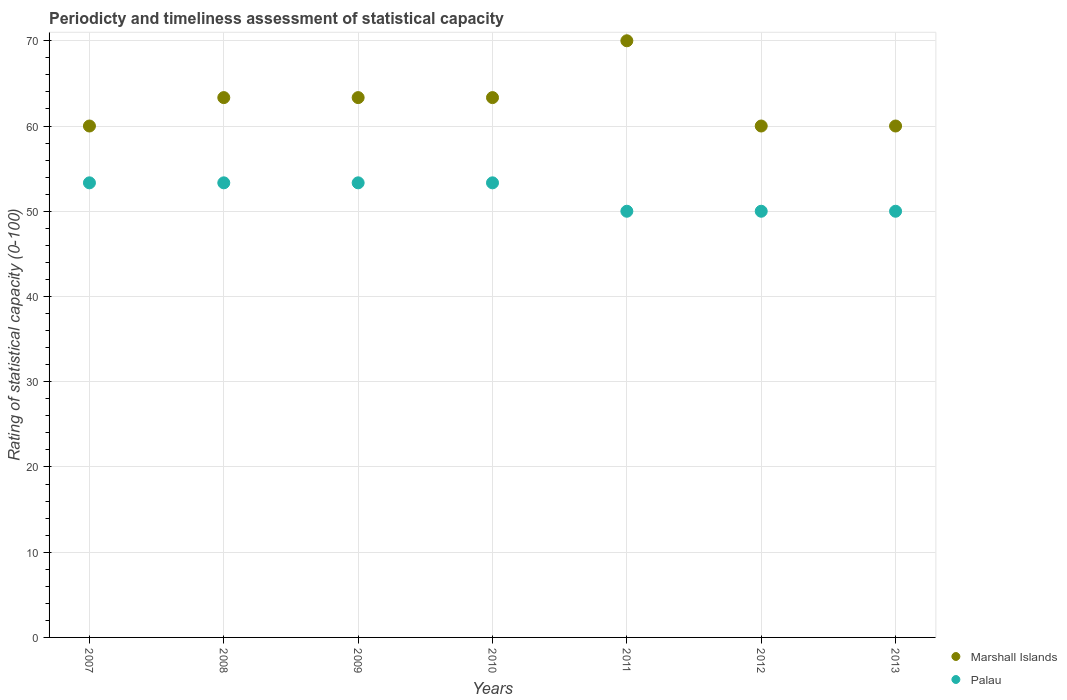How many different coloured dotlines are there?
Give a very brief answer. 2. Is the number of dotlines equal to the number of legend labels?
Your answer should be very brief. Yes. What is the total rating of statistical capacity in Palau in the graph?
Give a very brief answer. 363.33. What is the difference between the rating of statistical capacity in Marshall Islands in 2009 and the rating of statistical capacity in Palau in 2007?
Keep it short and to the point. 10. What is the average rating of statistical capacity in Palau per year?
Make the answer very short. 51.9. In the year 2007, what is the difference between the rating of statistical capacity in Marshall Islands and rating of statistical capacity in Palau?
Ensure brevity in your answer.  6.67. What is the ratio of the rating of statistical capacity in Marshall Islands in 2010 to that in 2012?
Offer a terse response. 1.06. Is the rating of statistical capacity in Palau in 2007 less than that in 2011?
Your response must be concise. No. Is the difference between the rating of statistical capacity in Marshall Islands in 2007 and 2010 greater than the difference between the rating of statistical capacity in Palau in 2007 and 2010?
Ensure brevity in your answer.  No. What is the difference between the highest and the lowest rating of statistical capacity in Palau?
Offer a terse response. 3.33. In how many years, is the rating of statistical capacity in Palau greater than the average rating of statistical capacity in Palau taken over all years?
Offer a terse response. 4. Is the sum of the rating of statistical capacity in Palau in 2011 and 2012 greater than the maximum rating of statistical capacity in Marshall Islands across all years?
Give a very brief answer. Yes. Is the rating of statistical capacity in Palau strictly less than the rating of statistical capacity in Marshall Islands over the years?
Give a very brief answer. Yes. What is the difference between two consecutive major ticks on the Y-axis?
Your response must be concise. 10. Does the graph contain any zero values?
Make the answer very short. No. Does the graph contain grids?
Make the answer very short. Yes. What is the title of the graph?
Your response must be concise. Periodicty and timeliness assessment of statistical capacity. Does "Moldova" appear as one of the legend labels in the graph?
Keep it short and to the point. No. What is the label or title of the Y-axis?
Offer a terse response. Rating of statistical capacity (0-100). What is the Rating of statistical capacity (0-100) in Marshall Islands in 2007?
Your response must be concise. 60. What is the Rating of statistical capacity (0-100) of Palau in 2007?
Offer a very short reply. 53.33. What is the Rating of statistical capacity (0-100) of Marshall Islands in 2008?
Your answer should be very brief. 63.33. What is the Rating of statistical capacity (0-100) in Palau in 2008?
Provide a succinct answer. 53.33. What is the Rating of statistical capacity (0-100) in Marshall Islands in 2009?
Give a very brief answer. 63.33. What is the Rating of statistical capacity (0-100) in Palau in 2009?
Keep it short and to the point. 53.33. What is the Rating of statistical capacity (0-100) of Marshall Islands in 2010?
Ensure brevity in your answer.  63.33. What is the Rating of statistical capacity (0-100) of Palau in 2010?
Make the answer very short. 53.33. What is the Rating of statistical capacity (0-100) in Marshall Islands in 2012?
Your answer should be very brief. 60. What is the Rating of statistical capacity (0-100) in Palau in 2012?
Offer a very short reply. 50. What is the Rating of statistical capacity (0-100) in Marshall Islands in 2013?
Your answer should be very brief. 60. What is the Rating of statistical capacity (0-100) of Palau in 2013?
Your response must be concise. 50. Across all years, what is the maximum Rating of statistical capacity (0-100) of Palau?
Ensure brevity in your answer.  53.33. What is the total Rating of statistical capacity (0-100) in Marshall Islands in the graph?
Provide a succinct answer. 440. What is the total Rating of statistical capacity (0-100) of Palau in the graph?
Your answer should be very brief. 363.33. What is the difference between the Rating of statistical capacity (0-100) of Marshall Islands in 2007 and that in 2008?
Ensure brevity in your answer.  -3.33. What is the difference between the Rating of statistical capacity (0-100) in Marshall Islands in 2007 and that in 2010?
Ensure brevity in your answer.  -3.33. What is the difference between the Rating of statistical capacity (0-100) in Palau in 2007 and that in 2010?
Your response must be concise. 0. What is the difference between the Rating of statistical capacity (0-100) of Marshall Islands in 2007 and that in 2011?
Offer a terse response. -10. What is the difference between the Rating of statistical capacity (0-100) of Palau in 2007 and that in 2011?
Your response must be concise. 3.33. What is the difference between the Rating of statistical capacity (0-100) in Palau in 2007 and that in 2012?
Give a very brief answer. 3.33. What is the difference between the Rating of statistical capacity (0-100) of Marshall Islands in 2007 and that in 2013?
Make the answer very short. 0. What is the difference between the Rating of statistical capacity (0-100) of Palau in 2008 and that in 2009?
Offer a terse response. 0. What is the difference between the Rating of statistical capacity (0-100) in Marshall Islands in 2008 and that in 2010?
Make the answer very short. 0. What is the difference between the Rating of statistical capacity (0-100) of Marshall Islands in 2008 and that in 2011?
Your answer should be very brief. -6.67. What is the difference between the Rating of statistical capacity (0-100) of Marshall Islands in 2008 and that in 2012?
Keep it short and to the point. 3.33. What is the difference between the Rating of statistical capacity (0-100) of Palau in 2008 and that in 2013?
Give a very brief answer. 3.33. What is the difference between the Rating of statistical capacity (0-100) of Marshall Islands in 2009 and that in 2011?
Give a very brief answer. -6.67. What is the difference between the Rating of statistical capacity (0-100) of Marshall Islands in 2009 and that in 2012?
Offer a terse response. 3.33. What is the difference between the Rating of statistical capacity (0-100) of Palau in 2009 and that in 2013?
Provide a succinct answer. 3.33. What is the difference between the Rating of statistical capacity (0-100) in Marshall Islands in 2010 and that in 2011?
Your answer should be compact. -6.67. What is the difference between the Rating of statistical capacity (0-100) of Marshall Islands in 2010 and that in 2012?
Make the answer very short. 3.33. What is the difference between the Rating of statistical capacity (0-100) in Palau in 2010 and that in 2012?
Give a very brief answer. 3.33. What is the difference between the Rating of statistical capacity (0-100) of Marshall Islands in 2010 and that in 2013?
Provide a short and direct response. 3.33. What is the difference between the Rating of statistical capacity (0-100) in Palau in 2010 and that in 2013?
Your answer should be compact. 3.33. What is the difference between the Rating of statistical capacity (0-100) in Marshall Islands in 2011 and that in 2012?
Offer a very short reply. 10. What is the difference between the Rating of statistical capacity (0-100) in Marshall Islands in 2012 and that in 2013?
Give a very brief answer. 0. What is the difference between the Rating of statistical capacity (0-100) of Palau in 2012 and that in 2013?
Your response must be concise. 0. What is the difference between the Rating of statistical capacity (0-100) of Marshall Islands in 2007 and the Rating of statistical capacity (0-100) of Palau in 2008?
Give a very brief answer. 6.67. What is the difference between the Rating of statistical capacity (0-100) in Marshall Islands in 2007 and the Rating of statistical capacity (0-100) in Palau in 2010?
Your response must be concise. 6.67. What is the difference between the Rating of statistical capacity (0-100) of Marshall Islands in 2007 and the Rating of statistical capacity (0-100) of Palau in 2011?
Offer a very short reply. 10. What is the difference between the Rating of statistical capacity (0-100) in Marshall Islands in 2008 and the Rating of statistical capacity (0-100) in Palau in 2011?
Make the answer very short. 13.33. What is the difference between the Rating of statistical capacity (0-100) of Marshall Islands in 2008 and the Rating of statistical capacity (0-100) of Palau in 2012?
Your response must be concise. 13.33. What is the difference between the Rating of statistical capacity (0-100) of Marshall Islands in 2008 and the Rating of statistical capacity (0-100) of Palau in 2013?
Give a very brief answer. 13.33. What is the difference between the Rating of statistical capacity (0-100) in Marshall Islands in 2009 and the Rating of statistical capacity (0-100) in Palau in 2011?
Your answer should be compact. 13.33. What is the difference between the Rating of statistical capacity (0-100) of Marshall Islands in 2009 and the Rating of statistical capacity (0-100) of Palau in 2012?
Make the answer very short. 13.33. What is the difference between the Rating of statistical capacity (0-100) in Marshall Islands in 2009 and the Rating of statistical capacity (0-100) in Palau in 2013?
Ensure brevity in your answer.  13.33. What is the difference between the Rating of statistical capacity (0-100) in Marshall Islands in 2010 and the Rating of statistical capacity (0-100) in Palau in 2011?
Offer a terse response. 13.33. What is the difference between the Rating of statistical capacity (0-100) in Marshall Islands in 2010 and the Rating of statistical capacity (0-100) in Palau in 2012?
Your answer should be very brief. 13.33. What is the difference between the Rating of statistical capacity (0-100) in Marshall Islands in 2010 and the Rating of statistical capacity (0-100) in Palau in 2013?
Offer a terse response. 13.33. What is the difference between the Rating of statistical capacity (0-100) in Marshall Islands in 2011 and the Rating of statistical capacity (0-100) in Palau in 2012?
Make the answer very short. 20. What is the difference between the Rating of statistical capacity (0-100) in Marshall Islands in 2011 and the Rating of statistical capacity (0-100) in Palau in 2013?
Provide a short and direct response. 20. What is the difference between the Rating of statistical capacity (0-100) of Marshall Islands in 2012 and the Rating of statistical capacity (0-100) of Palau in 2013?
Ensure brevity in your answer.  10. What is the average Rating of statistical capacity (0-100) of Marshall Islands per year?
Your answer should be very brief. 62.86. What is the average Rating of statistical capacity (0-100) of Palau per year?
Your answer should be very brief. 51.9. In the year 2007, what is the difference between the Rating of statistical capacity (0-100) of Marshall Islands and Rating of statistical capacity (0-100) of Palau?
Offer a very short reply. 6.67. In the year 2013, what is the difference between the Rating of statistical capacity (0-100) of Marshall Islands and Rating of statistical capacity (0-100) of Palau?
Your answer should be compact. 10. What is the ratio of the Rating of statistical capacity (0-100) of Marshall Islands in 2007 to that in 2008?
Give a very brief answer. 0.95. What is the ratio of the Rating of statistical capacity (0-100) in Palau in 2007 to that in 2008?
Give a very brief answer. 1. What is the ratio of the Rating of statistical capacity (0-100) of Marshall Islands in 2007 to that in 2009?
Keep it short and to the point. 0.95. What is the ratio of the Rating of statistical capacity (0-100) in Palau in 2007 to that in 2009?
Your answer should be compact. 1. What is the ratio of the Rating of statistical capacity (0-100) of Marshall Islands in 2007 to that in 2010?
Make the answer very short. 0.95. What is the ratio of the Rating of statistical capacity (0-100) of Palau in 2007 to that in 2010?
Your answer should be very brief. 1. What is the ratio of the Rating of statistical capacity (0-100) in Palau in 2007 to that in 2011?
Offer a terse response. 1.07. What is the ratio of the Rating of statistical capacity (0-100) of Marshall Islands in 2007 to that in 2012?
Your answer should be very brief. 1. What is the ratio of the Rating of statistical capacity (0-100) of Palau in 2007 to that in 2012?
Make the answer very short. 1.07. What is the ratio of the Rating of statistical capacity (0-100) of Marshall Islands in 2007 to that in 2013?
Make the answer very short. 1. What is the ratio of the Rating of statistical capacity (0-100) of Palau in 2007 to that in 2013?
Your response must be concise. 1.07. What is the ratio of the Rating of statistical capacity (0-100) of Marshall Islands in 2008 to that in 2009?
Offer a very short reply. 1. What is the ratio of the Rating of statistical capacity (0-100) in Marshall Islands in 2008 to that in 2010?
Offer a terse response. 1. What is the ratio of the Rating of statistical capacity (0-100) in Palau in 2008 to that in 2010?
Offer a very short reply. 1. What is the ratio of the Rating of statistical capacity (0-100) of Marshall Islands in 2008 to that in 2011?
Give a very brief answer. 0.9. What is the ratio of the Rating of statistical capacity (0-100) of Palau in 2008 to that in 2011?
Give a very brief answer. 1.07. What is the ratio of the Rating of statistical capacity (0-100) of Marshall Islands in 2008 to that in 2012?
Offer a very short reply. 1.06. What is the ratio of the Rating of statistical capacity (0-100) of Palau in 2008 to that in 2012?
Your response must be concise. 1.07. What is the ratio of the Rating of statistical capacity (0-100) of Marshall Islands in 2008 to that in 2013?
Provide a short and direct response. 1.06. What is the ratio of the Rating of statistical capacity (0-100) in Palau in 2008 to that in 2013?
Ensure brevity in your answer.  1.07. What is the ratio of the Rating of statistical capacity (0-100) in Marshall Islands in 2009 to that in 2010?
Your answer should be compact. 1. What is the ratio of the Rating of statistical capacity (0-100) in Marshall Islands in 2009 to that in 2011?
Ensure brevity in your answer.  0.9. What is the ratio of the Rating of statistical capacity (0-100) in Palau in 2009 to that in 2011?
Your response must be concise. 1.07. What is the ratio of the Rating of statistical capacity (0-100) in Marshall Islands in 2009 to that in 2012?
Ensure brevity in your answer.  1.06. What is the ratio of the Rating of statistical capacity (0-100) in Palau in 2009 to that in 2012?
Your response must be concise. 1.07. What is the ratio of the Rating of statistical capacity (0-100) of Marshall Islands in 2009 to that in 2013?
Give a very brief answer. 1.06. What is the ratio of the Rating of statistical capacity (0-100) of Palau in 2009 to that in 2013?
Keep it short and to the point. 1.07. What is the ratio of the Rating of statistical capacity (0-100) of Marshall Islands in 2010 to that in 2011?
Ensure brevity in your answer.  0.9. What is the ratio of the Rating of statistical capacity (0-100) in Palau in 2010 to that in 2011?
Your answer should be very brief. 1.07. What is the ratio of the Rating of statistical capacity (0-100) in Marshall Islands in 2010 to that in 2012?
Offer a very short reply. 1.06. What is the ratio of the Rating of statistical capacity (0-100) in Palau in 2010 to that in 2012?
Make the answer very short. 1.07. What is the ratio of the Rating of statistical capacity (0-100) in Marshall Islands in 2010 to that in 2013?
Keep it short and to the point. 1.06. What is the ratio of the Rating of statistical capacity (0-100) in Palau in 2010 to that in 2013?
Keep it short and to the point. 1.07. What is the ratio of the Rating of statistical capacity (0-100) in Marshall Islands in 2011 to that in 2012?
Your response must be concise. 1.17. What is the ratio of the Rating of statistical capacity (0-100) in Palau in 2011 to that in 2012?
Provide a succinct answer. 1. What is the ratio of the Rating of statistical capacity (0-100) of Marshall Islands in 2011 to that in 2013?
Make the answer very short. 1.17. What is the ratio of the Rating of statistical capacity (0-100) of Marshall Islands in 2012 to that in 2013?
Offer a very short reply. 1. What is the ratio of the Rating of statistical capacity (0-100) of Palau in 2012 to that in 2013?
Provide a short and direct response. 1. What is the difference between the highest and the second highest Rating of statistical capacity (0-100) of Marshall Islands?
Make the answer very short. 6.67. What is the difference between the highest and the second highest Rating of statistical capacity (0-100) of Palau?
Your answer should be compact. 0. What is the difference between the highest and the lowest Rating of statistical capacity (0-100) in Marshall Islands?
Provide a succinct answer. 10. What is the difference between the highest and the lowest Rating of statistical capacity (0-100) in Palau?
Your answer should be very brief. 3.33. 